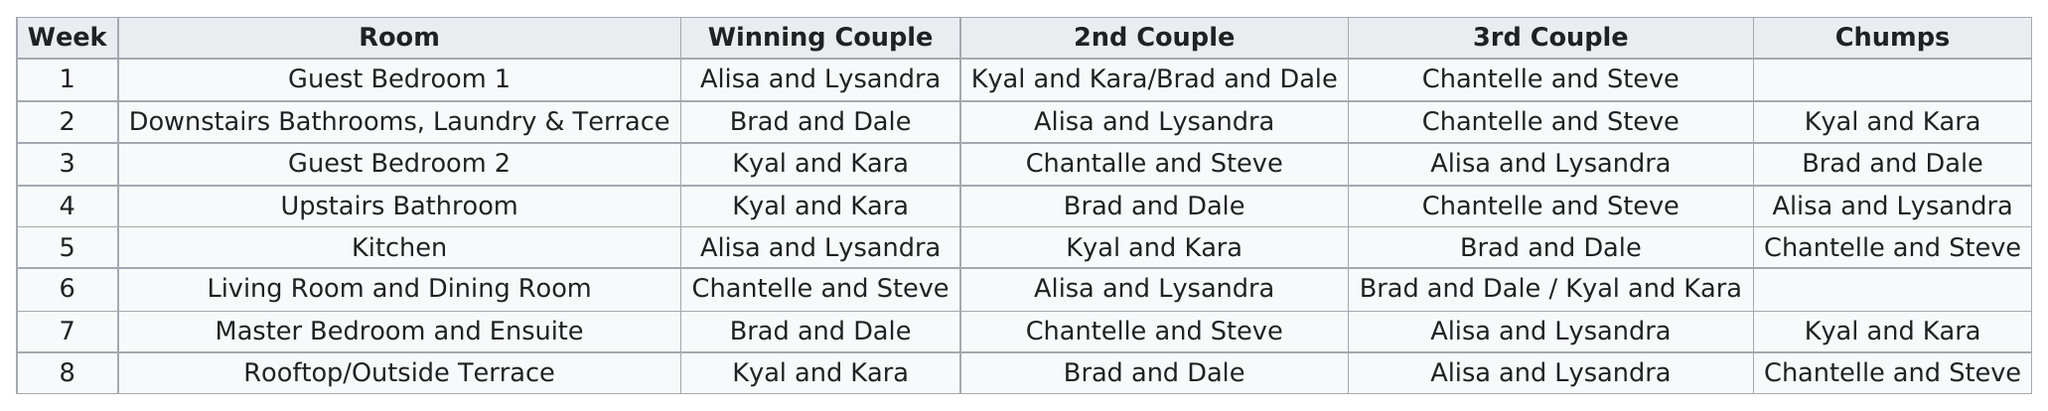Indicate a few pertinent items in this graphic. The individuals known as Chantelle and Steve were identified as the culprits in the kitchen. Chantelle and Steve were the third couple for how many weeks? Kyal and Kara were the chumps who were in the same situation as Chantelle and Steve. After winning in week 5, Alisa and Lysandra had zero winning weeks. The last time Alisa and Lysandra were the 2nd couple, they practiced dancing in the living room and dining room. 